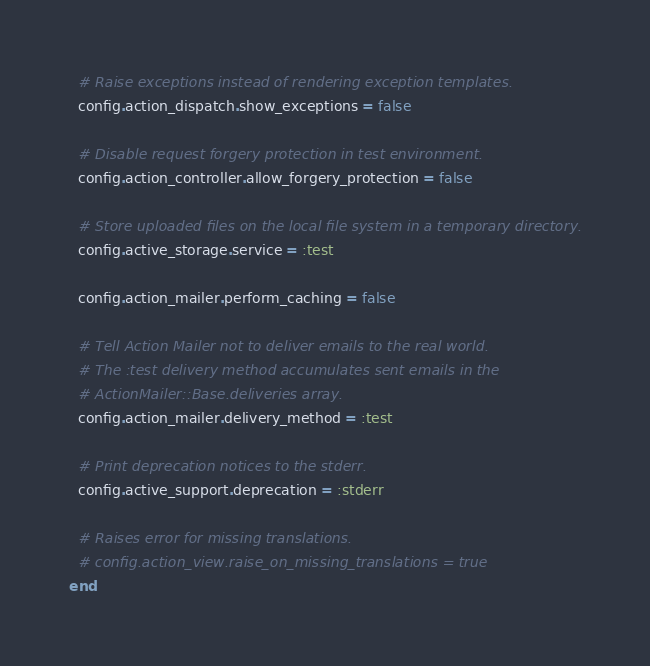Convert code to text. <code><loc_0><loc_0><loc_500><loc_500><_Ruby_>  # Raise exceptions instead of rendering exception templates.
  config.action_dispatch.show_exceptions = false

  # Disable request forgery protection in test environment.
  config.action_controller.allow_forgery_protection = false

  # Store uploaded files on the local file system in a temporary directory.
  config.active_storage.service = :test

  config.action_mailer.perform_caching = false

  # Tell Action Mailer not to deliver emails to the real world.
  # The :test delivery method accumulates sent emails in the
  # ActionMailer::Base.deliveries array.
  config.action_mailer.delivery_method = :test

  # Print deprecation notices to the stderr.
  config.active_support.deprecation = :stderr

  # Raises error for missing translations.
  # config.action_view.raise_on_missing_translations = true
end
</code> 